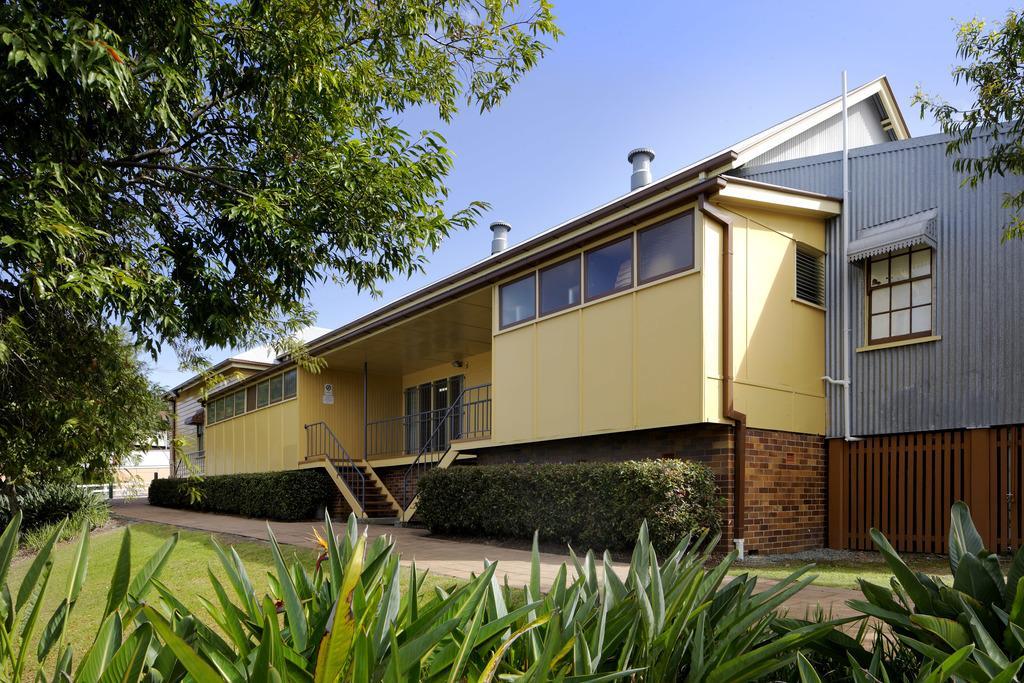Please provide a concise description of this image. This is grass. There are plants, trees, and a house. In the background there is sky. 